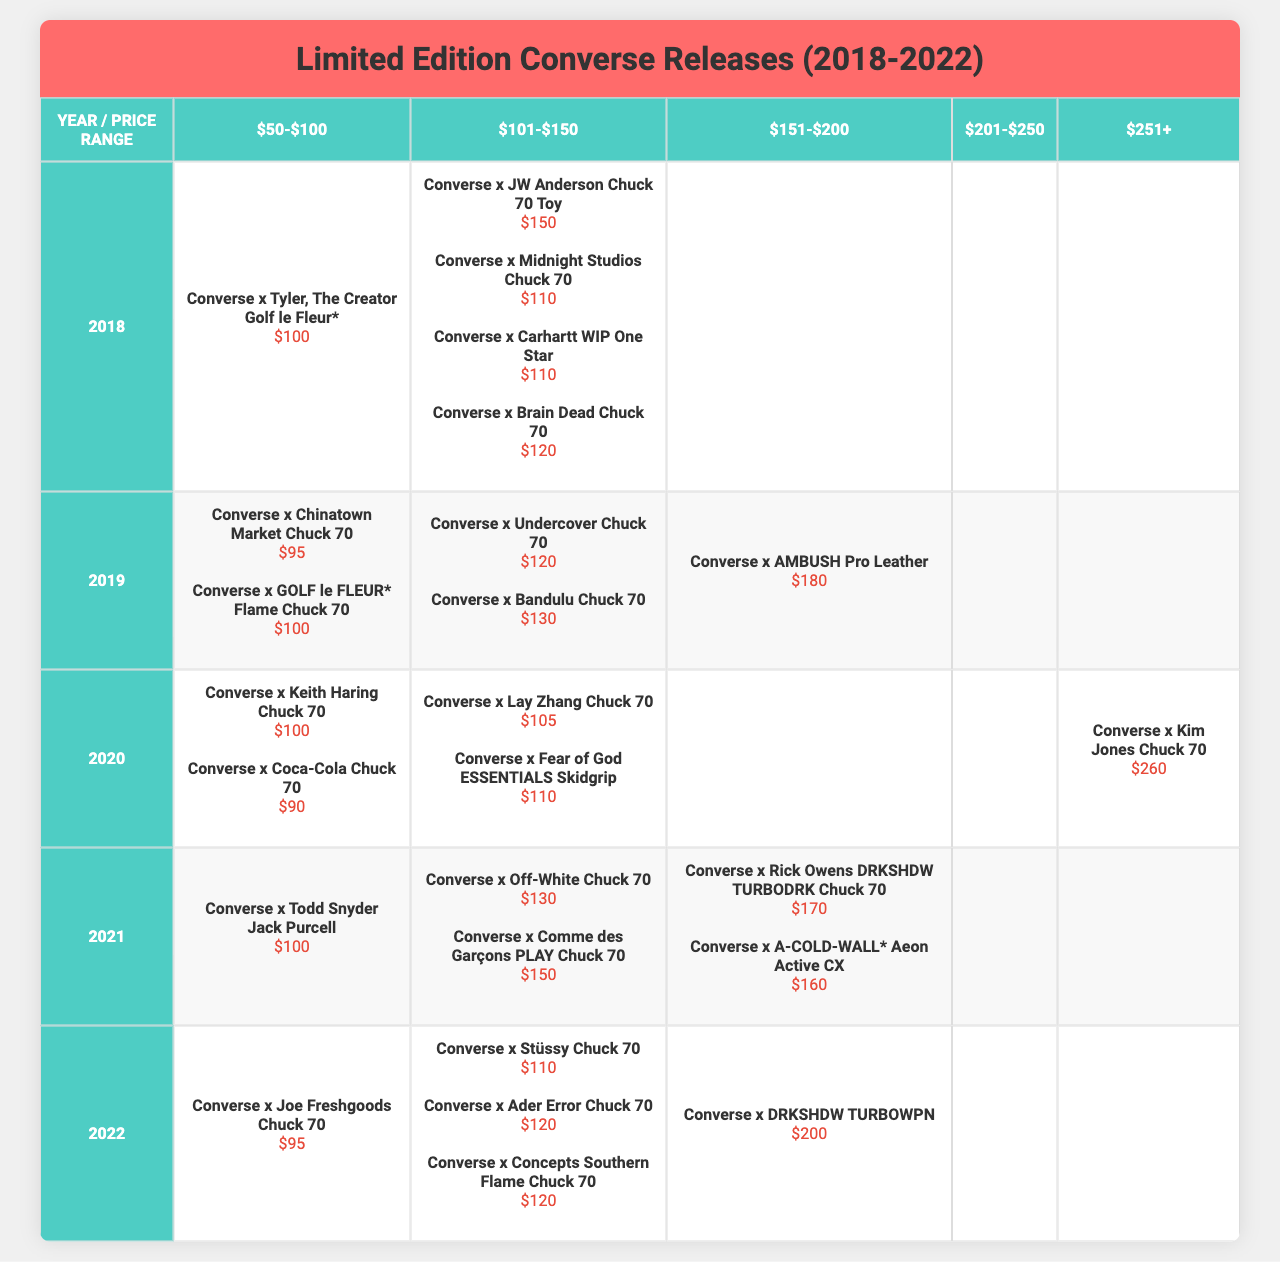What was the most expensive limited edition Converse release in 2021? The most expensive release in 2021 is "Converse x Rick Owens DRKSHDW TURBODRK Chuck 70" priced at $170.
Answer: $170 How many limited edition releases were priced between $50 and $100 in 2019? In 2019, there are two releases that fall within this price range: "Converse x Chinatown Market Chuck 70" at $95 and "Converse x GOLF le FLEUR* Flame Chuck 70" at $100. Thus, the total is 2.
Answer: 2 Which year saw the release of the Converse x Kim Jones Chuck 70? The Converse x Kim Jones Chuck 70 was released in 2020, where it is listed at a price of $260.
Answer: 2020 How many releases in the 2022 data were priced above $200? In 2022, there is one release priced above $200, which is "Converse x DRKSHDW TURBOWPN" at $200.
Answer: 0 What is the average price of all released Converse sneakers in 2018? The prices in 2018 are $150, $100, $110, $110, and $120. The total is $600 and there are 5 releases, leading to an average price of $600/5 = $120.
Answer: $120 Did any of the releases in 2020 have a price between $151 and $200? Yes, the "Converse x Kim Jones Chuck 70" is listed at $260, which is greater than $200, while the others fall under or match $200.
Answer: Yes How many unique price ranges were used for releases in the year 2021? In 2021, the price ranges represented among the releases are $100-$150, $151-$200, and $201+, which totals 3 unique ranges.
Answer: 3 Which limited edition release was the cheapest in 2019? The cheapest release in 2019 is "Converse x Chinatown Market Chuck 70" priced at $95.
Answer: $95 What is the total number of releases across all years? By summing up all the releases from each year (5 in 2018, 5 in 2019, 5 in 2020, 5 in 2021, and 5 in 2022), there are a total of 25 releases across all years.
Answer: 25 How many releases in 2021 were priced under $150? In 2021, there are 3 releases priced under $150: "Converse x Todd Snyder Jack Purcell" at $100, "Converse x Off-White Chuck 70" at $130, and "Converse x Comme des Garçons PLAY Chuck 70" at $150.
Answer: 3 What percentage of total releases in 2020 are priced above $100? In 2020, there are 5 total releases, of which 2 are priced above $100 ("Converse x Lay Zhang Chuck 70" at $105 and "Converse x Kim Jones Chuck 70" at $260). This makes the percentage 2/5 = 40%.
Answer: 40% 